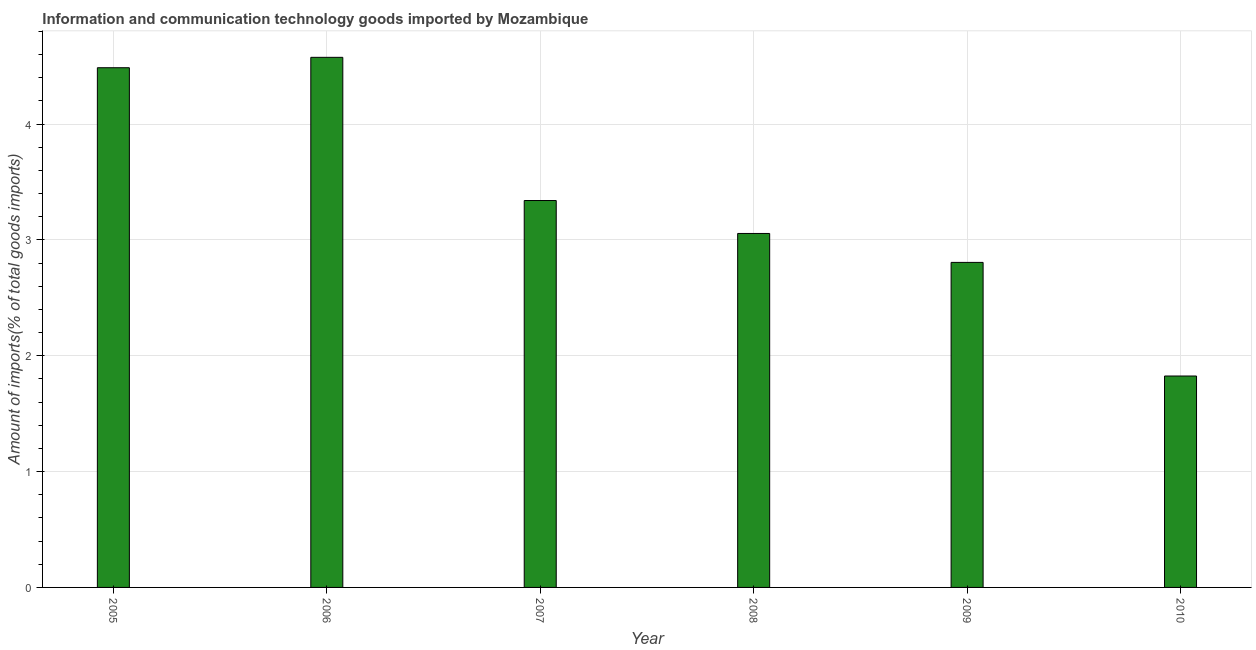Does the graph contain any zero values?
Provide a succinct answer. No. What is the title of the graph?
Keep it short and to the point. Information and communication technology goods imported by Mozambique. What is the label or title of the X-axis?
Make the answer very short. Year. What is the label or title of the Y-axis?
Your answer should be compact. Amount of imports(% of total goods imports). What is the amount of ict goods imports in 2010?
Offer a very short reply. 1.83. Across all years, what is the maximum amount of ict goods imports?
Offer a very short reply. 4.58. Across all years, what is the minimum amount of ict goods imports?
Provide a short and direct response. 1.83. In which year was the amount of ict goods imports maximum?
Offer a terse response. 2006. In which year was the amount of ict goods imports minimum?
Ensure brevity in your answer.  2010. What is the sum of the amount of ict goods imports?
Offer a very short reply. 20.09. What is the difference between the amount of ict goods imports in 2008 and 2010?
Provide a succinct answer. 1.23. What is the average amount of ict goods imports per year?
Your response must be concise. 3.35. What is the median amount of ict goods imports?
Give a very brief answer. 3.2. What is the ratio of the amount of ict goods imports in 2007 to that in 2009?
Make the answer very short. 1.19. Is the amount of ict goods imports in 2008 less than that in 2009?
Provide a succinct answer. No. Is the difference between the amount of ict goods imports in 2008 and 2010 greater than the difference between any two years?
Provide a succinct answer. No. What is the difference between the highest and the second highest amount of ict goods imports?
Provide a short and direct response. 0.09. Is the sum of the amount of ict goods imports in 2006 and 2007 greater than the maximum amount of ict goods imports across all years?
Offer a terse response. Yes. What is the difference between the highest and the lowest amount of ict goods imports?
Provide a short and direct response. 2.75. How many bars are there?
Keep it short and to the point. 6. Are all the bars in the graph horizontal?
Make the answer very short. No. What is the difference between two consecutive major ticks on the Y-axis?
Provide a short and direct response. 1. Are the values on the major ticks of Y-axis written in scientific E-notation?
Your answer should be very brief. No. What is the Amount of imports(% of total goods imports) in 2005?
Offer a very short reply. 4.49. What is the Amount of imports(% of total goods imports) of 2006?
Offer a terse response. 4.58. What is the Amount of imports(% of total goods imports) of 2007?
Provide a short and direct response. 3.34. What is the Amount of imports(% of total goods imports) of 2008?
Your answer should be very brief. 3.06. What is the Amount of imports(% of total goods imports) of 2009?
Your answer should be compact. 2.81. What is the Amount of imports(% of total goods imports) of 2010?
Your answer should be compact. 1.83. What is the difference between the Amount of imports(% of total goods imports) in 2005 and 2006?
Your response must be concise. -0.09. What is the difference between the Amount of imports(% of total goods imports) in 2005 and 2007?
Your response must be concise. 1.15. What is the difference between the Amount of imports(% of total goods imports) in 2005 and 2008?
Provide a succinct answer. 1.43. What is the difference between the Amount of imports(% of total goods imports) in 2005 and 2009?
Your response must be concise. 1.68. What is the difference between the Amount of imports(% of total goods imports) in 2005 and 2010?
Give a very brief answer. 2.66. What is the difference between the Amount of imports(% of total goods imports) in 2006 and 2007?
Your answer should be very brief. 1.24. What is the difference between the Amount of imports(% of total goods imports) in 2006 and 2008?
Offer a terse response. 1.52. What is the difference between the Amount of imports(% of total goods imports) in 2006 and 2009?
Your answer should be compact. 1.77. What is the difference between the Amount of imports(% of total goods imports) in 2006 and 2010?
Your answer should be very brief. 2.75. What is the difference between the Amount of imports(% of total goods imports) in 2007 and 2008?
Your answer should be very brief. 0.28. What is the difference between the Amount of imports(% of total goods imports) in 2007 and 2009?
Make the answer very short. 0.53. What is the difference between the Amount of imports(% of total goods imports) in 2007 and 2010?
Ensure brevity in your answer.  1.52. What is the difference between the Amount of imports(% of total goods imports) in 2008 and 2009?
Ensure brevity in your answer.  0.25. What is the difference between the Amount of imports(% of total goods imports) in 2008 and 2010?
Give a very brief answer. 1.23. What is the difference between the Amount of imports(% of total goods imports) in 2009 and 2010?
Your answer should be very brief. 0.98. What is the ratio of the Amount of imports(% of total goods imports) in 2005 to that in 2007?
Make the answer very short. 1.34. What is the ratio of the Amount of imports(% of total goods imports) in 2005 to that in 2008?
Provide a short and direct response. 1.47. What is the ratio of the Amount of imports(% of total goods imports) in 2005 to that in 2009?
Offer a very short reply. 1.6. What is the ratio of the Amount of imports(% of total goods imports) in 2005 to that in 2010?
Your answer should be compact. 2.46. What is the ratio of the Amount of imports(% of total goods imports) in 2006 to that in 2007?
Your answer should be compact. 1.37. What is the ratio of the Amount of imports(% of total goods imports) in 2006 to that in 2008?
Your answer should be very brief. 1.5. What is the ratio of the Amount of imports(% of total goods imports) in 2006 to that in 2009?
Provide a short and direct response. 1.63. What is the ratio of the Amount of imports(% of total goods imports) in 2006 to that in 2010?
Make the answer very short. 2.51. What is the ratio of the Amount of imports(% of total goods imports) in 2007 to that in 2008?
Your answer should be compact. 1.09. What is the ratio of the Amount of imports(% of total goods imports) in 2007 to that in 2009?
Offer a terse response. 1.19. What is the ratio of the Amount of imports(% of total goods imports) in 2007 to that in 2010?
Keep it short and to the point. 1.83. What is the ratio of the Amount of imports(% of total goods imports) in 2008 to that in 2009?
Keep it short and to the point. 1.09. What is the ratio of the Amount of imports(% of total goods imports) in 2008 to that in 2010?
Give a very brief answer. 1.67. What is the ratio of the Amount of imports(% of total goods imports) in 2009 to that in 2010?
Offer a very short reply. 1.54. 